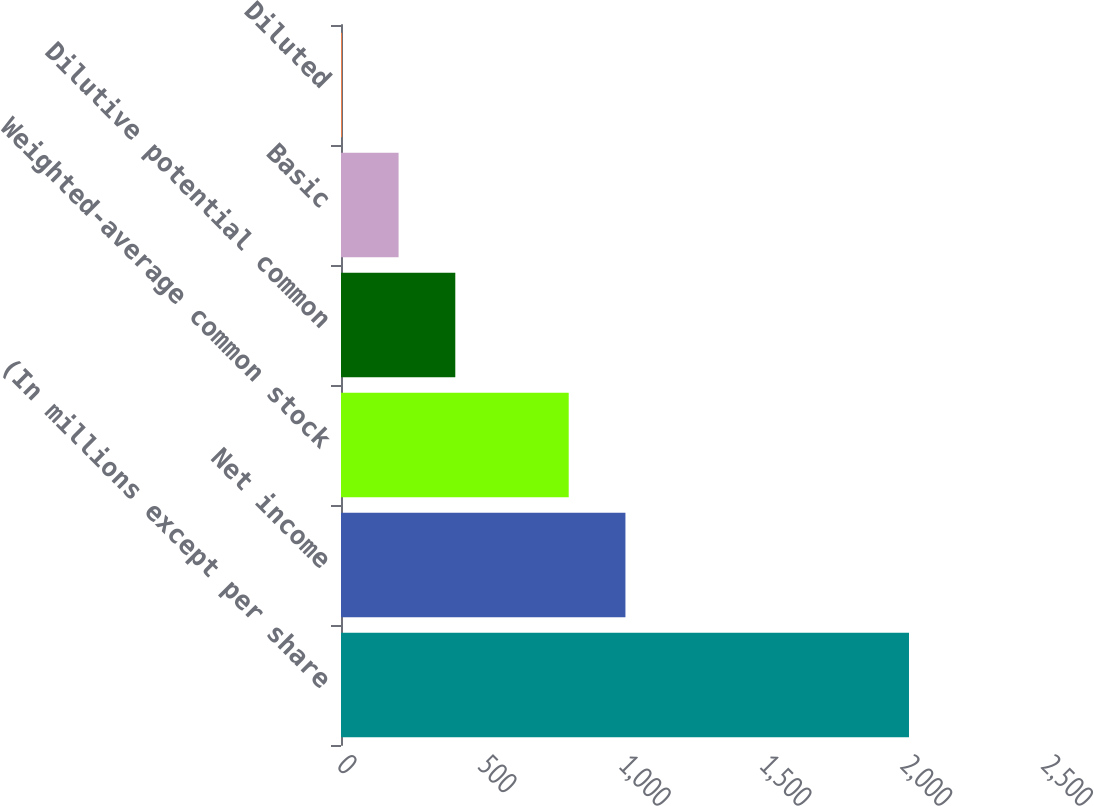Convert chart. <chart><loc_0><loc_0><loc_500><loc_500><bar_chart><fcel>(In millions except per share<fcel>Net income<fcel>Weighted-average common stock<fcel>Dilutive potential common<fcel>Basic<fcel>Diluted<nl><fcel>2017<fcel>1010.03<fcel>808.64<fcel>405.86<fcel>204.47<fcel>3.08<nl></chart> 